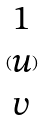Convert formula to latex. <formula><loc_0><loc_0><loc_500><loc_500>( \begin{matrix} 1 \\ u \\ v \end{matrix} )</formula> 